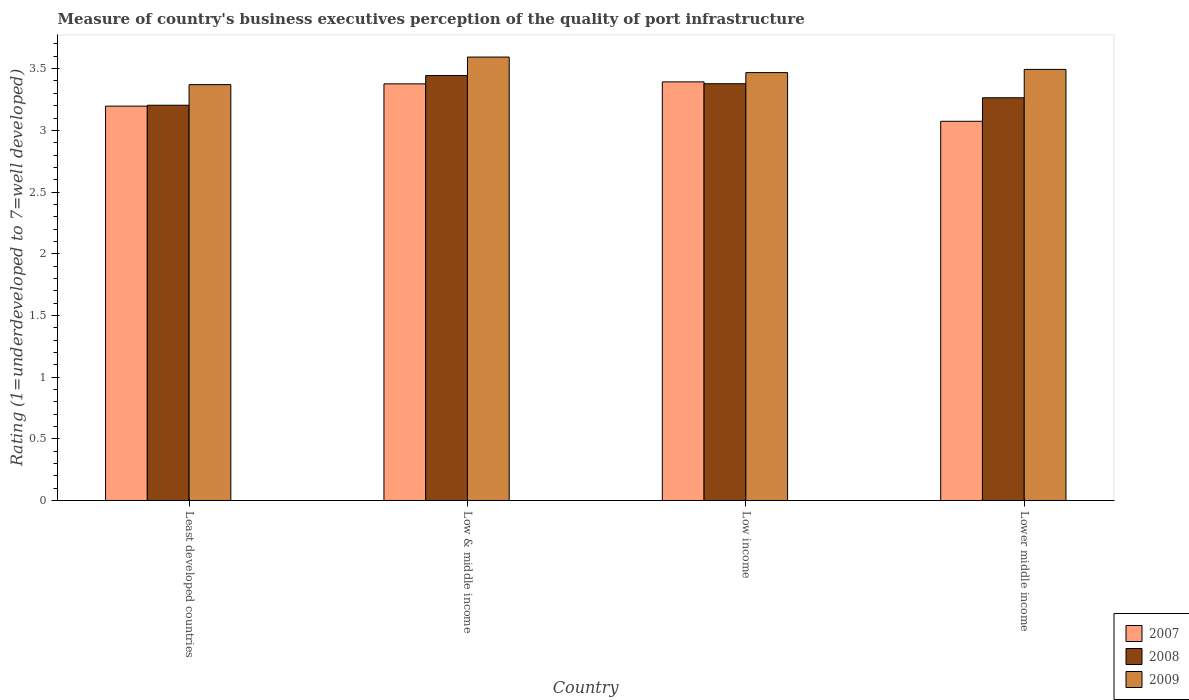Are the number of bars per tick equal to the number of legend labels?
Provide a succinct answer. Yes. Are the number of bars on each tick of the X-axis equal?
Offer a very short reply. Yes. How many bars are there on the 3rd tick from the left?
Ensure brevity in your answer.  3. How many bars are there on the 3rd tick from the right?
Keep it short and to the point. 3. What is the label of the 2nd group of bars from the left?
Ensure brevity in your answer.  Low & middle income. In how many cases, is the number of bars for a given country not equal to the number of legend labels?
Offer a terse response. 0. What is the ratings of the quality of port infrastructure in 2008 in Low income?
Give a very brief answer. 3.38. Across all countries, what is the maximum ratings of the quality of port infrastructure in 2009?
Ensure brevity in your answer.  3.59. Across all countries, what is the minimum ratings of the quality of port infrastructure in 2008?
Offer a terse response. 3.2. In which country was the ratings of the quality of port infrastructure in 2007 minimum?
Make the answer very short. Lower middle income. What is the total ratings of the quality of port infrastructure in 2007 in the graph?
Provide a succinct answer. 13.04. What is the difference between the ratings of the quality of port infrastructure in 2009 in Least developed countries and that in Low income?
Give a very brief answer. -0.1. What is the difference between the ratings of the quality of port infrastructure in 2008 in Low & middle income and the ratings of the quality of port infrastructure in 2007 in Least developed countries?
Your answer should be very brief. 0.25. What is the average ratings of the quality of port infrastructure in 2009 per country?
Keep it short and to the point. 3.48. What is the difference between the ratings of the quality of port infrastructure of/in 2009 and ratings of the quality of port infrastructure of/in 2007 in Lower middle income?
Offer a very short reply. 0.42. In how many countries, is the ratings of the quality of port infrastructure in 2009 greater than 2.6?
Make the answer very short. 4. What is the ratio of the ratings of the quality of port infrastructure in 2009 in Least developed countries to that in Low income?
Make the answer very short. 0.97. Is the ratings of the quality of port infrastructure in 2007 in Least developed countries less than that in Lower middle income?
Your answer should be compact. No. What is the difference between the highest and the second highest ratings of the quality of port infrastructure in 2007?
Your response must be concise. 0.18. What is the difference between the highest and the lowest ratings of the quality of port infrastructure in 2007?
Provide a short and direct response. 0.32. Is the sum of the ratings of the quality of port infrastructure in 2008 in Least developed countries and Low income greater than the maximum ratings of the quality of port infrastructure in 2007 across all countries?
Give a very brief answer. Yes. What does the 1st bar from the left in Lower middle income represents?
Your response must be concise. 2007. Does the graph contain any zero values?
Ensure brevity in your answer.  No. Does the graph contain grids?
Provide a short and direct response. No. What is the title of the graph?
Offer a very short reply. Measure of country's business executives perception of the quality of port infrastructure. What is the label or title of the Y-axis?
Your response must be concise. Rating (1=underdeveloped to 7=well developed). What is the Rating (1=underdeveloped to 7=well developed) of 2007 in Least developed countries?
Your response must be concise. 3.2. What is the Rating (1=underdeveloped to 7=well developed) in 2008 in Least developed countries?
Offer a terse response. 3.2. What is the Rating (1=underdeveloped to 7=well developed) of 2009 in Least developed countries?
Your answer should be very brief. 3.37. What is the Rating (1=underdeveloped to 7=well developed) of 2007 in Low & middle income?
Offer a terse response. 3.38. What is the Rating (1=underdeveloped to 7=well developed) in 2008 in Low & middle income?
Ensure brevity in your answer.  3.44. What is the Rating (1=underdeveloped to 7=well developed) in 2009 in Low & middle income?
Your answer should be very brief. 3.59. What is the Rating (1=underdeveloped to 7=well developed) in 2007 in Low income?
Your response must be concise. 3.39. What is the Rating (1=underdeveloped to 7=well developed) in 2008 in Low income?
Keep it short and to the point. 3.38. What is the Rating (1=underdeveloped to 7=well developed) of 2009 in Low income?
Give a very brief answer. 3.47. What is the Rating (1=underdeveloped to 7=well developed) in 2007 in Lower middle income?
Offer a very short reply. 3.07. What is the Rating (1=underdeveloped to 7=well developed) in 2008 in Lower middle income?
Offer a very short reply. 3.26. What is the Rating (1=underdeveloped to 7=well developed) of 2009 in Lower middle income?
Provide a succinct answer. 3.49. Across all countries, what is the maximum Rating (1=underdeveloped to 7=well developed) of 2007?
Give a very brief answer. 3.39. Across all countries, what is the maximum Rating (1=underdeveloped to 7=well developed) in 2008?
Keep it short and to the point. 3.44. Across all countries, what is the maximum Rating (1=underdeveloped to 7=well developed) of 2009?
Ensure brevity in your answer.  3.59. Across all countries, what is the minimum Rating (1=underdeveloped to 7=well developed) of 2007?
Your answer should be compact. 3.07. Across all countries, what is the minimum Rating (1=underdeveloped to 7=well developed) of 2008?
Offer a very short reply. 3.2. Across all countries, what is the minimum Rating (1=underdeveloped to 7=well developed) of 2009?
Keep it short and to the point. 3.37. What is the total Rating (1=underdeveloped to 7=well developed) of 2007 in the graph?
Your answer should be compact. 13.04. What is the total Rating (1=underdeveloped to 7=well developed) in 2008 in the graph?
Your answer should be very brief. 13.29. What is the total Rating (1=underdeveloped to 7=well developed) of 2009 in the graph?
Keep it short and to the point. 13.93. What is the difference between the Rating (1=underdeveloped to 7=well developed) in 2007 in Least developed countries and that in Low & middle income?
Your response must be concise. -0.18. What is the difference between the Rating (1=underdeveloped to 7=well developed) of 2008 in Least developed countries and that in Low & middle income?
Your response must be concise. -0.24. What is the difference between the Rating (1=underdeveloped to 7=well developed) in 2009 in Least developed countries and that in Low & middle income?
Keep it short and to the point. -0.22. What is the difference between the Rating (1=underdeveloped to 7=well developed) of 2007 in Least developed countries and that in Low income?
Offer a very short reply. -0.2. What is the difference between the Rating (1=underdeveloped to 7=well developed) of 2008 in Least developed countries and that in Low income?
Keep it short and to the point. -0.17. What is the difference between the Rating (1=underdeveloped to 7=well developed) of 2009 in Least developed countries and that in Low income?
Ensure brevity in your answer.  -0.1. What is the difference between the Rating (1=underdeveloped to 7=well developed) of 2007 in Least developed countries and that in Lower middle income?
Give a very brief answer. 0.12. What is the difference between the Rating (1=underdeveloped to 7=well developed) of 2008 in Least developed countries and that in Lower middle income?
Keep it short and to the point. -0.06. What is the difference between the Rating (1=underdeveloped to 7=well developed) in 2009 in Least developed countries and that in Lower middle income?
Offer a terse response. -0.12. What is the difference between the Rating (1=underdeveloped to 7=well developed) in 2007 in Low & middle income and that in Low income?
Your answer should be very brief. -0.02. What is the difference between the Rating (1=underdeveloped to 7=well developed) in 2008 in Low & middle income and that in Low income?
Offer a very short reply. 0.07. What is the difference between the Rating (1=underdeveloped to 7=well developed) in 2009 in Low & middle income and that in Low income?
Ensure brevity in your answer.  0.13. What is the difference between the Rating (1=underdeveloped to 7=well developed) of 2007 in Low & middle income and that in Lower middle income?
Offer a very short reply. 0.3. What is the difference between the Rating (1=underdeveloped to 7=well developed) in 2008 in Low & middle income and that in Lower middle income?
Your answer should be very brief. 0.18. What is the difference between the Rating (1=underdeveloped to 7=well developed) of 2009 in Low & middle income and that in Lower middle income?
Provide a succinct answer. 0.1. What is the difference between the Rating (1=underdeveloped to 7=well developed) of 2007 in Low income and that in Lower middle income?
Offer a very short reply. 0.32. What is the difference between the Rating (1=underdeveloped to 7=well developed) in 2008 in Low income and that in Lower middle income?
Your answer should be compact. 0.11. What is the difference between the Rating (1=underdeveloped to 7=well developed) of 2009 in Low income and that in Lower middle income?
Give a very brief answer. -0.03. What is the difference between the Rating (1=underdeveloped to 7=well developed) of 2007 in Least developed countries and the Rating (1=underdeveloped to 7=well developed) of 2008 in Low & middle income?
Your answer should be compact. -0.25. What is the difference between the Rating (1=underdeveloped to 7=well developed) in 2007 in Least developed countries and the Rating (1=underdeveloped to 7=well developed) in 2009 in Low & middle income?
Keep it short and to the point. -0.4. What is the difference between the Rating (1=underdeveloped to 7=well developed) of 2008 in Least developed countries and the Rating (1=underdeveloped to 7=well developed) of 2009 in Low & middle income?
Give a very brief answer. -0.39. What is the difference between the Rating (1=underdeveloped to 7=well developed) of 2007 in Least developed countries and the Rating (1=underdeveloped to 7=well developed) of 2008 in Low income?
Ensure brevity in your answer.  -0.18. What is the difference between the Rating (1=underdeveloped to 7=well developed) in 2007 in Least developed countries and the Rating (1=underdeveloped to 7=well developed) in 2009 in Low income?
Give a very brief answer. -0.27. What is the difference between the Rating (1=underdeveloped to 7=well developed) of 2008 in Least developed countries and the Rating (1=underdeveloped to 7=well developed) of 2009 in Low income?
Keep it short and to the point. -0.26. What is the difference between the Rating (1=underdeveloped to 7=well developed) in 2007 in Least developed countries and the Rating (1=underdeveloped to 7=well developed) in 2008 in Lower middle income?
Offer a terse response. -0.07. What is the difference between the Rating (1=underdeveloped to 7=well developed) of 2007 in Least developed countries and the Rating (1=underdeveloped to 7=well developed) of 2009 in Lower middle income?
Provide a short and direct response. -0.3. What is the difference between the Rating (1=underdeveloped to 7=well developed) of 2008 in Least developed countries and the Rating (1=underdeveloped to 7=well developed) of 2009 in Lower middle income?
Provide a short and direct response. -0.29. What is the difference between the Rating (1=underdeveloped to 7=well developed) in 2007 in Low & middle income and the Rating (1=underdeveloped to 7=well developed) in 2008 in Low income?
Your answer should be very brief. -0. What is the difference between the Rating (1=underdeveloped to 7=well developed) in 2007 in Low & middle income and the Rating (1=underdeveloped to 7=well developed) in 2009 in Low income?
Ensure brevity in your answer.  -0.09. What is the difference between the Rating (1=underdeveloped to 7=well developed) of 2008 in Low & middle income and the Rating (1=underdeveloped to 7=well developed) of 2009 in Low income?
Offer a terse response. -0.02. What is the difference between the Rating (1=underdeveloped to 7=well developed) in 2007 in Low & middle income and the Rating (1=underdeveloped to 7=well developed) in 2008 in Lower middle income?
Offer a terse response. 0.11. What is the difference between the Rating (1=underdeveloped to 7=well developed) in 2007 in Low & middle income and the Rating (1=underdeveloped to 7=well developed) in 2009 in Lower middle income?
Provide a succinct answer. -0.12. What is the difference between the Rating (1=underdeveloped to 7=well developed) of 2008 in Low & middle income and the Rating (1=underdeveloped to 7=well developed) of 2009 in Lower middle income?
Your answer should be very brief. -0.05. What is the difference between the Rating (1=underdeveloped to 7=well developed) of 2007 in Low income and the Rating (1=underdeveloped to 7=well developed) of 2008 in Lower middle income?
Provide a short and direct response. 0.13. What is the difference between the Rating (1=underdeveloped to 7=well developed) in 2007 in Low income and the Rating (1=underdeveloped to 7=well developed) in 2009 in Lower middle income?
Your response must be concise. -0.1. What is the difference between the Rating (1=underdeveloped to 7=well developed) in 2008 in Low income and the Rating (1=underdeveloped to 7=well developed) in 2009 in Lower middle income?
Your response must be concise. -0.12. What is the average Rating (1=underdeveloped to 7=well developed) in 2007 per country?
Your response must be concise. 3.26. What is the average Rating (1=underdeveloped to 7=well developed) of 2008 per country?
Your answer should be very brief. 3.32. What is the average Rating (1=underdeveloped to 7=well developed) of 2009 per country?
Your response must be concise. 3.48. What is the difference between the Rating (1=underdeveloped to 7=well developed) in 2007 and Rating (1=underdeveloped to 7=well developed) in 2008 in Least developed countries?
Give a very brief answer. -0.01. What is the difference between the Rating (1=underdeveloped to 7=well developed) of 2007 and Rating (1=underdeveloped to 7=well developed) of 2009 in Least developed countries?
Provide a succinct answer. -0.17. What is the difference between the Rating (1=underdeveloped to 7=well developed) of 2008 and Rating (1=underdeveloped to 7=well developed) of 2009 in Least developed countries?
Provide a succinct answer. -0.17. What is the difference between the Rating (1=underdeveloped to 7=well developed) of 2007 and Rating (1=underdeveloped to 7=well developed) of 2008 in Low & middle income?
Provide a succinct answer. -0.07. What is the difference between the Rating (1=underdeveloped to 7=well developed) in 2007 and Rating (1=underdeveloped to 7=well developed) in 2009 in Low & middle income?
Offer a terse response. -0.22. What is the difference between the Rating (1=underdeveloped to 7=well developed) of 2008 and Rating (1=underdeveloped to 7=well developed) of 2009 in Low & middle income?
Your answer should be very brief. -0.15. What is the difference between the Rating (1=underdeveloped to 7=well developed) in 2007 and Rating (1=underdeveloped to 7=well developed) in 2008 in Low income?
Offer a terse response. 0.01. What is the difference between the Rating (1=underdeveloped to 7=well developed) of 2007 and Rating (1=underdeveloped to 7=well developed) of 2009 in Low income?
Give a very brief answer. -0.08. What is the difference between the Rating (1=underdeveloped to 7=well developed) in 2008 and Rating (1=underdeveloped to 7=well developed) in 2009 in Low income?
Make the answer very short. -0.09. What is the difference between the Rating (1=underdeveloped to 7=well developed) in 2007 and Rating (1=underdeveloped to 7=well developed) in 2008 in Lower middle income?
Make the answer very short. -0.19. What is the difference between the Rating (1=underdeveloped to 7=well developed) of 2007 and Rating (1=underdeveloped to 7=well developed) of 2009 in Lower middle income?
Ensure brevity in your answer.  -0.42. What is the difference between the Rating (1=underdeveloped to 7=well developed) of 2008 and Rating (1=underdeveloped to 7=well developed) of 2009 in Lower middle income?
Your answer should be compact. -0.23. What is the ratio of the Rating (1=underdeveloped to 7=well developed) in 2007 in Least developed countries to that in Low & middle income?
Make the answer very short. 0.95. What is the ratio of the Rating (1=underdeveloped to 7=well developed) of 2008 in Least developed countries to that in Low & middle income?
Ensure brevity in your answer.  0.93. What is the ratio of the Rating (1=underdeveloped to 7=well developed) in 2009 in Least developed countries to that in Low & middle income?
Your answer should be compact. 0.94. What is the ratio of the Rating (1=underdeveloped to 7=well developed) in 2007 in Least developed countries to that in Low income?
Offer a very short reply. 0.94. What is the ratio of the Rating (1=underdeveloped to 7=well developed) in 2008 in Least developed countries to that in Low income?
Provide a short and direct response. 0.95. What is the ratio of the Rating (1=underdeveloped to 7=well developed) of 2009 in Least developed countries to that in Low income?
Your answer should be compact. 0.97. What is the ratio of the Rating (1=underdeveloped to 7=well developed) in 2008 in Least developed countries to that in Lower middle income?
Keep it short and to the point. 0.98. What is the ratio of the Rating (1=underdeveloped to 7=well developed) of 2009 in Least developed countries to that in Lower middle income?
Make the answer very short. 0.96. What is the ratio of the Rating (1=underdeveloped to 7=well developed) in 2007 in Low & middle income to that in Low income?
Ensure brevity in your answer.  1. What is the ratio of the Rating (1=underdeveloped to 7=well developed) of 2008 in Low & middle income to that in Low income?
Ensure brevity in your answer.  1.02. What is the ratio of the Rating (1=underdeveloped to 7=well developed) in 2009 in Low & middle income to that in Low income?
Offer a terse response. 1.04. What is the ratio of the Rating (1=underdeveloped to 7=well developed) of 2007 in Low & middle income to that in Lower middle income?
Offer a terse response. 1.1. What is the ratio of the Rating (1=underdeveloped to 7=well developed) in 2008 in Low & middle income to that in Lower middle income?
Provide a succinct answer. 1.06. What is the ratio of the Rating (1=underdeveloped to 7=well developed) of 2009 in Low & middle income to that in Lower middle income?
Make the answer very short. 1.03. What is the ratio of the Rating (1=underdeveloped to 7=well developed) of 2007 in Low income to that in Lower middle income?
Make the answer very short. 1.1. What is the ratio of the Rating (1=underdeveloped to 7=well developed) of 2008 in Low income to that in Lower middle income?
Make the answer very short. 1.03. What is the ratio of the Rating (1=underdeveloped to 7=well developed) in 2009 in Low income to that in Lower middle income?
Provide a short and direct response. 0.99. What is the difference between the highest and the second highest Rating (1=underdeveloped to 7=well developed) in 2007?
Your response must be concise. 0.02. What is the difference between the highest and the second highest Rating (1=underdeveloped to 7=well developed) in 2008?
Your response must be concise. 0.07. What is the difference between the highest and the second highest Rating (1=underdeveloped to 7=well developed) of 2009?
Give a very brief answer. 0.1. What is the difference between the highest and the lowest Rating (1=underdeveloped to 7=well developed) of 2007?
Your response must be concise. 0.32. What is the difference between the highest and the lowest Rating (1=underdeveloped to 7=well developed) of 2008?
Provide a short and direct response. 0.24. What is the difference between the highest and the lowest Rating (1=underdeveloped to 7=well developed) in 2009?
Give a very brief answer. 0.22. 